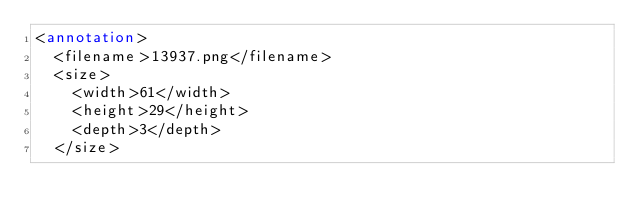<code> <loc_0><loc_0><loc_500><loc_500><_XML_><annotation>
  <filename>13937.png</filename>
  <size>
    <width>61</width>
    <height>29</height>
    <depth>3</depth>
  </size></code> 